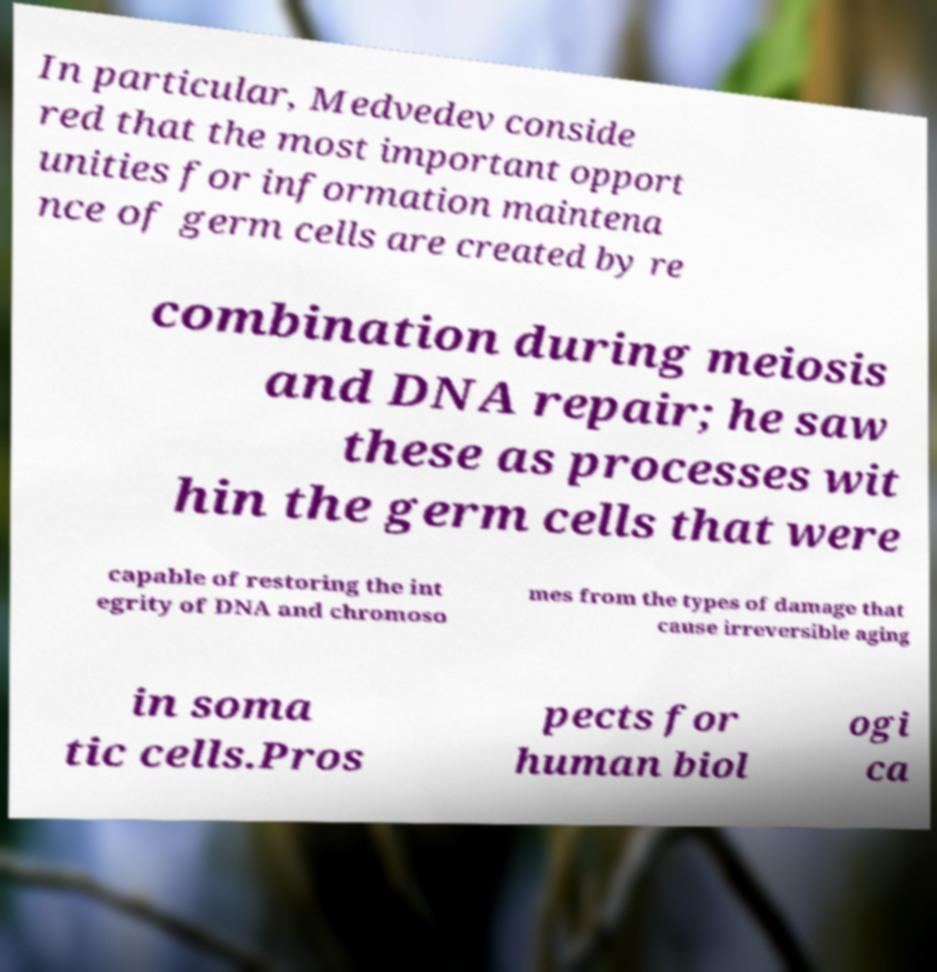Could you assist in decoding the text presented in this image and type it out clearly? In particular, Medvedev conside red that the most important opport unities for information maintena nce of germ cells are created by re combination during meiosis and DNA repair; he saw these as processes wit hin the germ cells that were capable of restoring the int egrity of DNA and chromoso mes from the types of damage that cause irreversible aging in soma tic cells.Pros pects for human biol ogi ca 